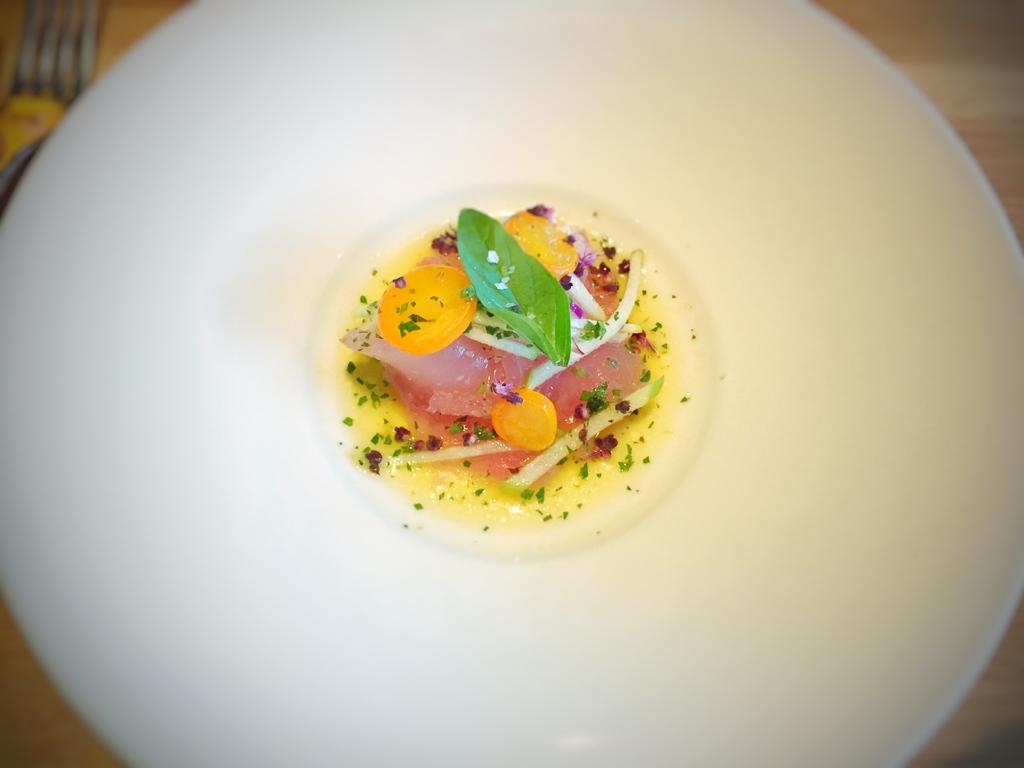What can be seen on the plate in the image? There is a food item on the plate in the image. Can you describe the plate in the image? The plate is visible in the image, but no specific details about its shape, color, or material are provided. What is the chance of the queen visiting the location where the plate is in the image? There is no information about the location or any royal visits in the image, so it is impossible to determine the likelihood of the queen visiting the location. 